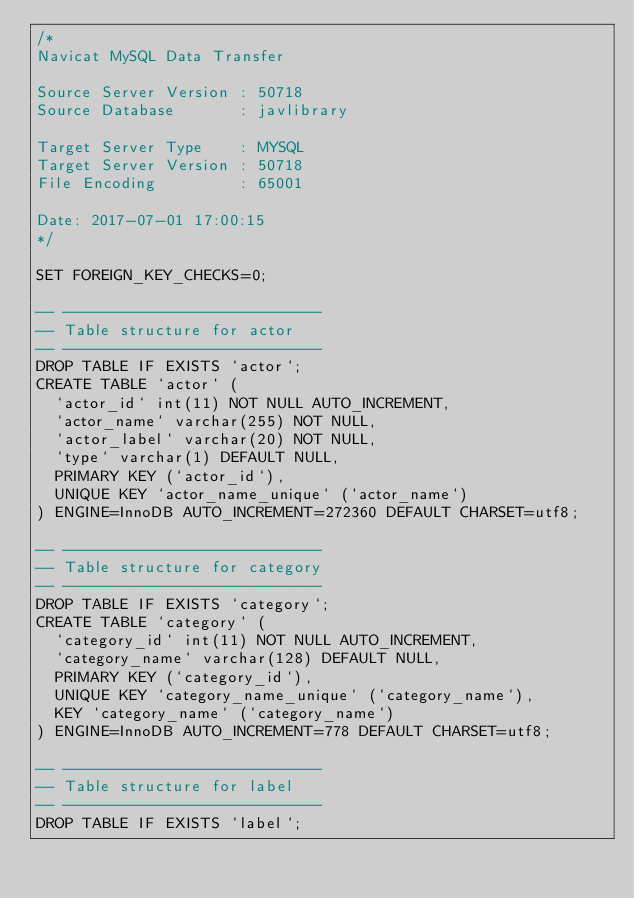Convert code to text. <code><loc_0><loc_0><loc_500><loc_500><_SQL_>/*
Navicat MySQL Data Transfer

Source Server Version : 50718
Source Database       : javlibrary

Target Server Type    : MYSQL
Target Server Version : 50718
File Encoding         : 65001

Date: 2017-07-01 17:00:15
*/

SET FOREIGN_KEY_CHECKS=0;

-- ----------------------------
-- Table structure for actor
-- ----------------------------
DROP TABLE IF EXISTS `actor`;
CREATE TABLE `actor` (
  `actor_id` int(11) NOT NULL AUTO_INCREMENT,
  `actor_name` varchar(255) NOT NULL,
  `actor_label` varchar(20) NOT NULL,
  `type` varchar(1) DEFAULT NULL,
  PRIMARY KEY (`actor_id`),
  UNIQUE KEY `actor_name_unique` (`actor_name`)
) ENGINE=InnoDB AUTO_INCREMENT=272360 DEFAULT CHARSET=utf8;

-- ----------------------------
-- Table structure for category
-- ----------------------------
DROP TABLE IF EXISTS `category`;
CREATE TABLE `category` (
  `category_id` int(11) NOT NULL AUTO_INCREMENT,
  `category_name` varchar(128) DEFAULT NULL,
  PRIMARY KEY (`category_id`),
  UNIQUE KEY `category_name_unique` (`category_name`),
  KEY `category_name` (`category_name`)
) ENGINE=InnoDB AUTO_INCREMENT=778 DEFAULT CHARSET=utf8;

-- ----------------------------
-- Table structure for label
-- ----------------------------
DROP TABLE IF EXISTS `label`;</code> 